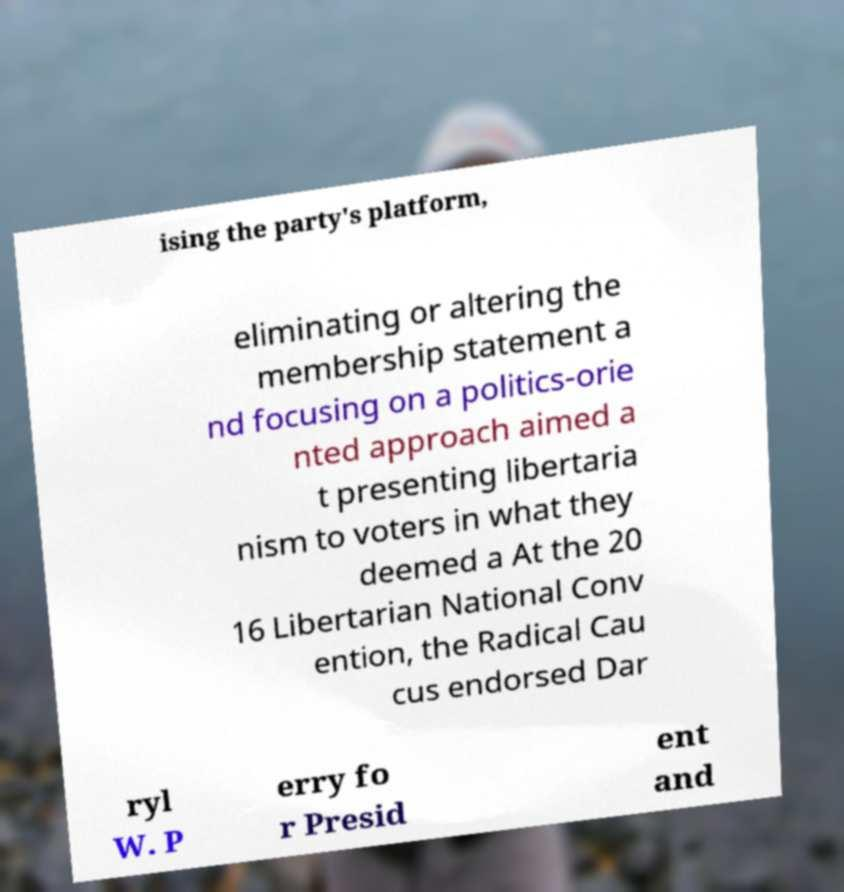Could you extract and type out the text from this image? ising the party's platform, eliminating or altering the membership statement a nd focusing on a politics-orie nted approach aimed a t presenting libertaria nism to voters in what they deemed a At the 20 16 Libertarian National Conv ention, the Radical Cau cus endorsed Dar ryl W. P erry fo r Presid ent and 